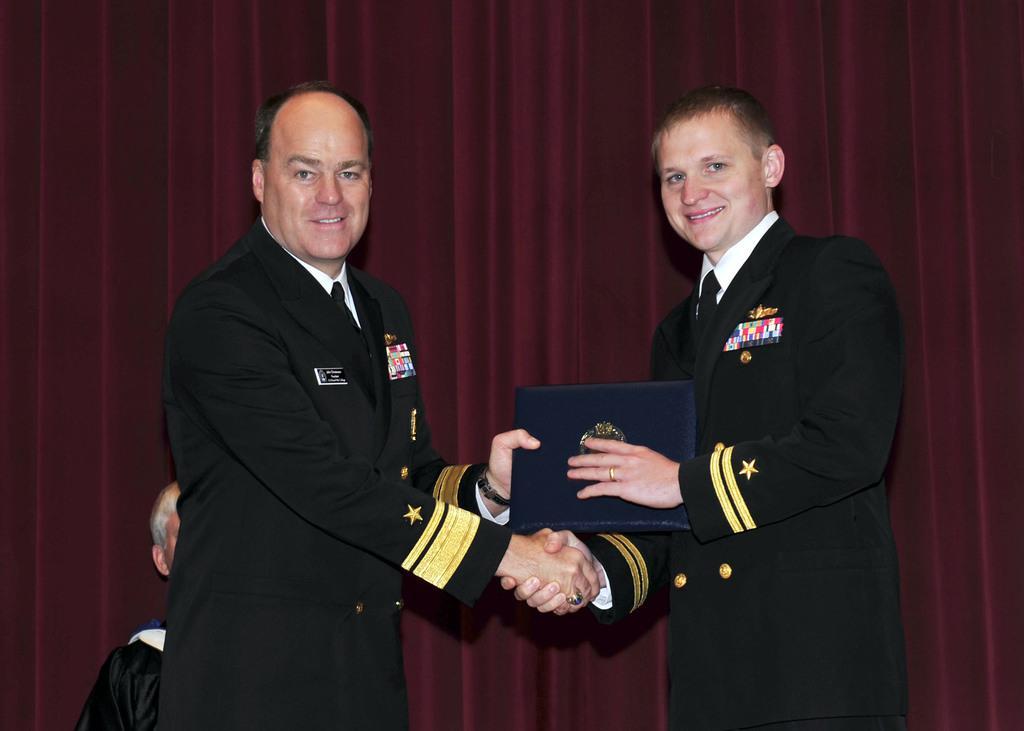In one or two sentences, can you explain what this image depicts? In this image we can see two persons wearing coat and ties are standing. One person is holding a file with an emblem on it. In the background, we can see a person and curtain. 